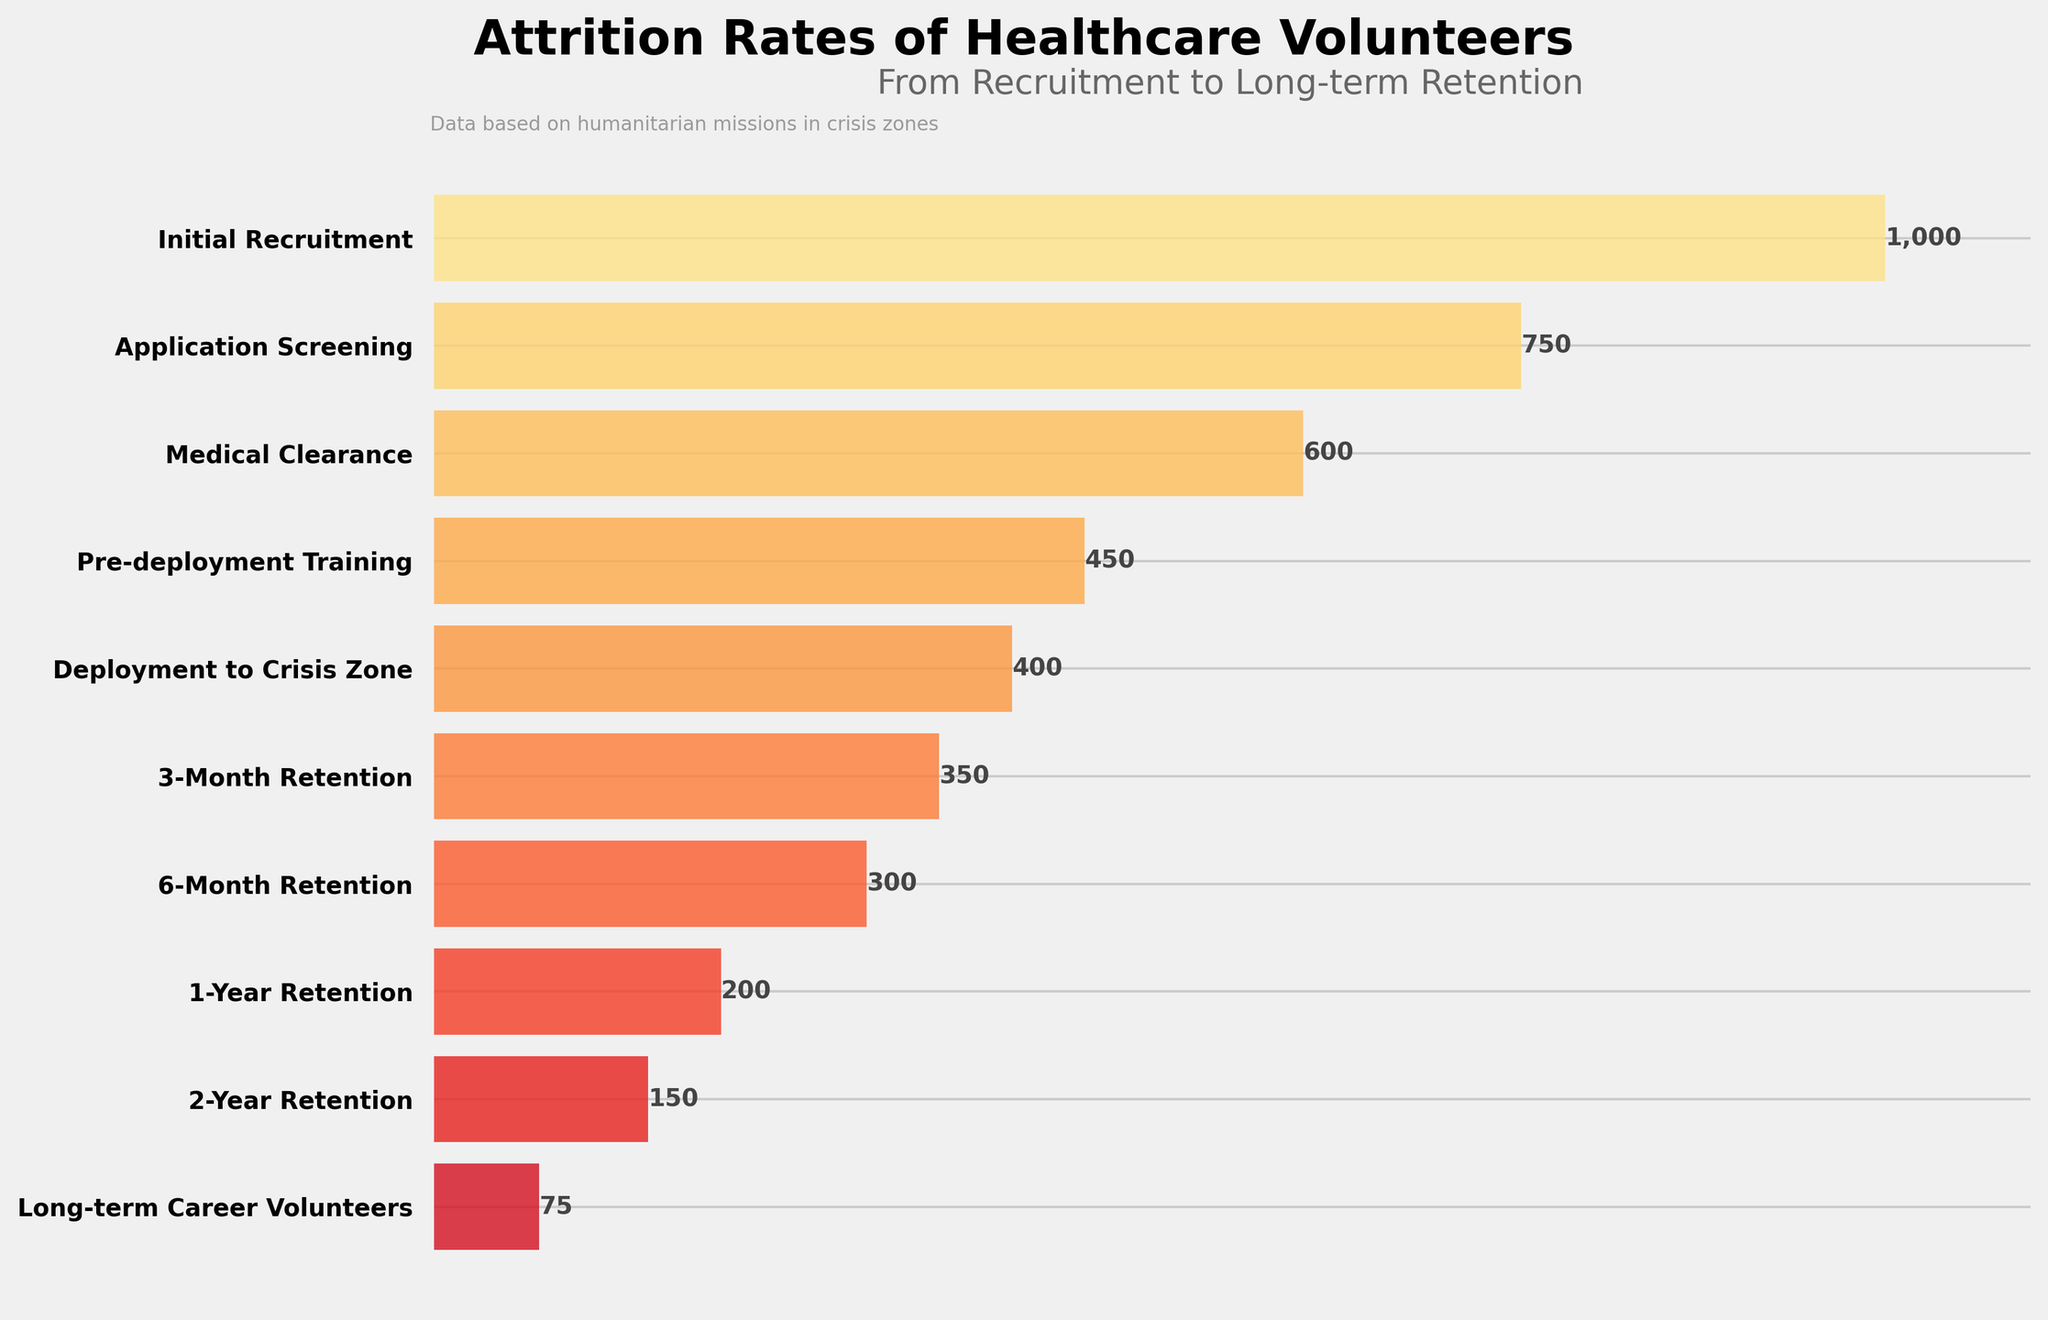How many volunteers were initially recruited? The figure shows the number of volunteers at each stage of the funnel. In the "Initial Recruitment" stage, we can see the label indicating the number of volunteers.
Answer: 1,000 What is the attrition rate from "Initial Recruitment" to "Application Screening"? To find the attrition rate, we subtract the number of volunteers in "Application Screening" from the number in "Initial Recruitment" and then divide by the "Initial Recruitment" number. Attrition rate = (1000 - 750) / 1000 = 0.25 or 25%.
Answer: 25% What percentage of volunteers make it to "3-Month Retention" after being deployed to the crisis zone? We find the number of volunteers who make it to "3-Month Retention" and divide it by the number of those deployed. This percentage is calculated as (350 / 400) * 100 = 87.5%.
Answer: 87.5% Which stage shows the largest drop in the number of volunteers? By examining the differences between consecutive stages, we see that the largest drop occurs between "Initial Recruitment" (1000) and "Application Screening" (750), a drop of 250 volunteers.
Answer: Application Screening How many fewer volunteers are there at "Long-term Career Volunteers" compared to "1-Year Retention"? We subtract the number of volunteers at "Long-term Career Volunteers" from those at the "1-Year Retention" stage, which is 200 - 75 = 125.
Answer: 125 What proportion of the initially recruited volunteers become long-term career volunteers? To determine this proportion, divide the number of long-term career volunteers by the number initially recruited: 75 / 1000 = 0.075 or 7.5%.
Answer: 7.5% Compare the volunteer retention rate between the "6-Month Retention" and the "1-Year Retention" stages. To find the retention rate, divide the number at "1-Year Retention" by the number at "6-Month Retention": (200 / 300) * 100 = 66.7%.
Answer: 66.7% How many volunteers leave after the "Medical Clearance" stage? We subtract the number of volunteers at "Pre-deployment Training" from those at "Medical Clearance": 600 - 450 = 150.
Answer: 150 What is the difference in the number of volunteers between the stage right before deployment and the stage right after deployment? The number of volunteers right before deployment ("Pre-deployment Training") is 450, and right after deployment ("Deployment to Crisis Zone") is 400. The difference is 450 - 400 = 50.
Answer: 50 At which stage does the number of volunteers first drop below half of the initial recruitments? Half of the initial recruitment is 1000 / 2 = 500. The number of volunteers drops below 500 at the "Pre-deployment Training" stage, where there are 450 volunteers.
Answer: Pre-deployment Training 